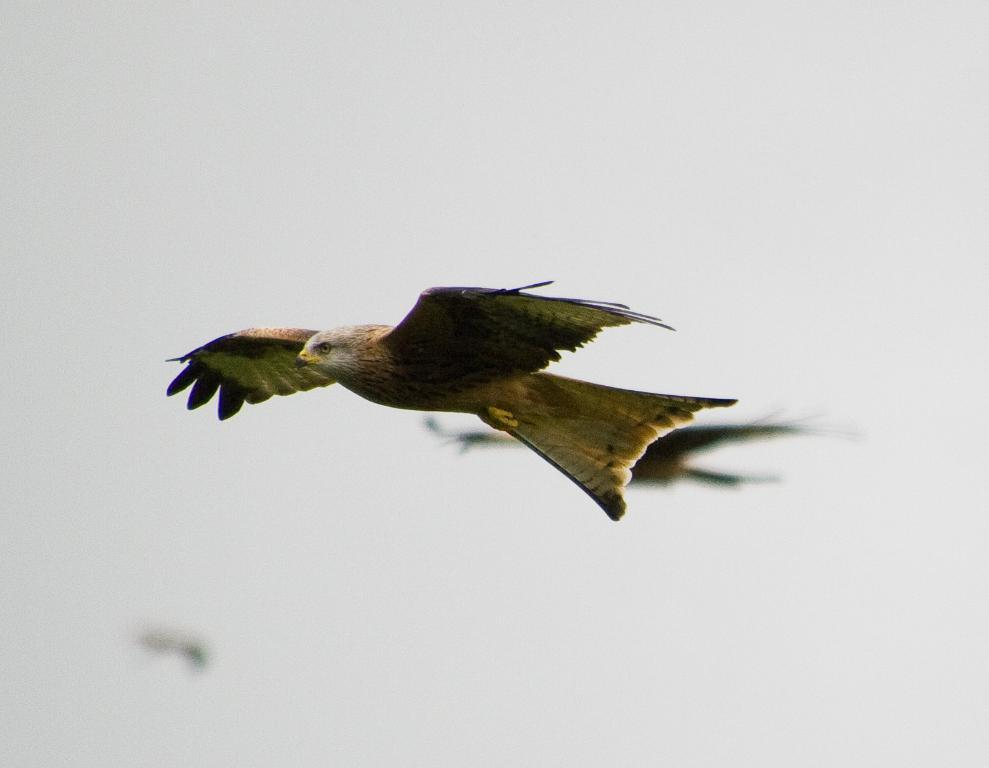What type of animals can be seen in the image? Birds can be seen in the image. What are the birds doing in the image? The birds are flying in the air. What type of process is the creature undergoing in the image? There is no creature present in the image, and therefore no process can be observed. 